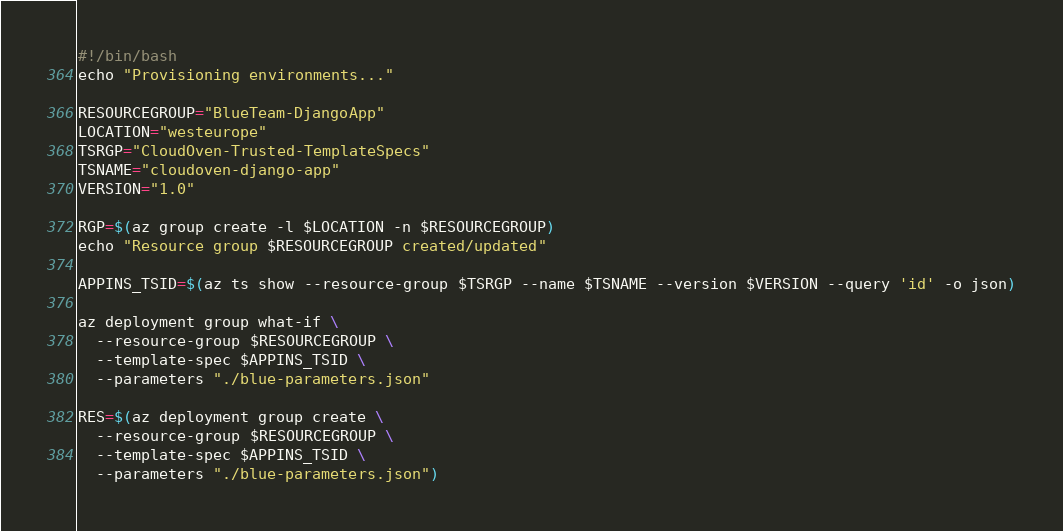Convert code to text. <code><loc_0><loc_0><loc_500><loc_500><_Bash_>#!/bin/bash
echo "Provisioning environments..."

RESOURCEGROUP="BlueTeam-DjangoApp"
LOCATION="westeurope"
TSRGP="CloudOven-Trusted-TemplateSpecs"
TSNAME="cloudoven-django-app"
VERSION="1.0"

RGP=$(az group create -l $LOCATION -n $RESOURCEGROUP)
echo "Resource group $RESOURCEGROUP created/updated"

APPINS_TSID=$(az ts show --resource-group $TSRGP --name $TSNAME --version $VERSION --query 'id' -o json)

az deployment group what-if \
  --resource-group $RESOURCEGROUP \
  --template-spec $APPINS_TSID \
  --parameters "./blue-parameters.json"

RES=$(az deployment group create \
  --resource-group $RESOURCEGROUP \
  --template-spec $APPINS_TSID \
  --parameters "./blue-parameters.json")</code> 